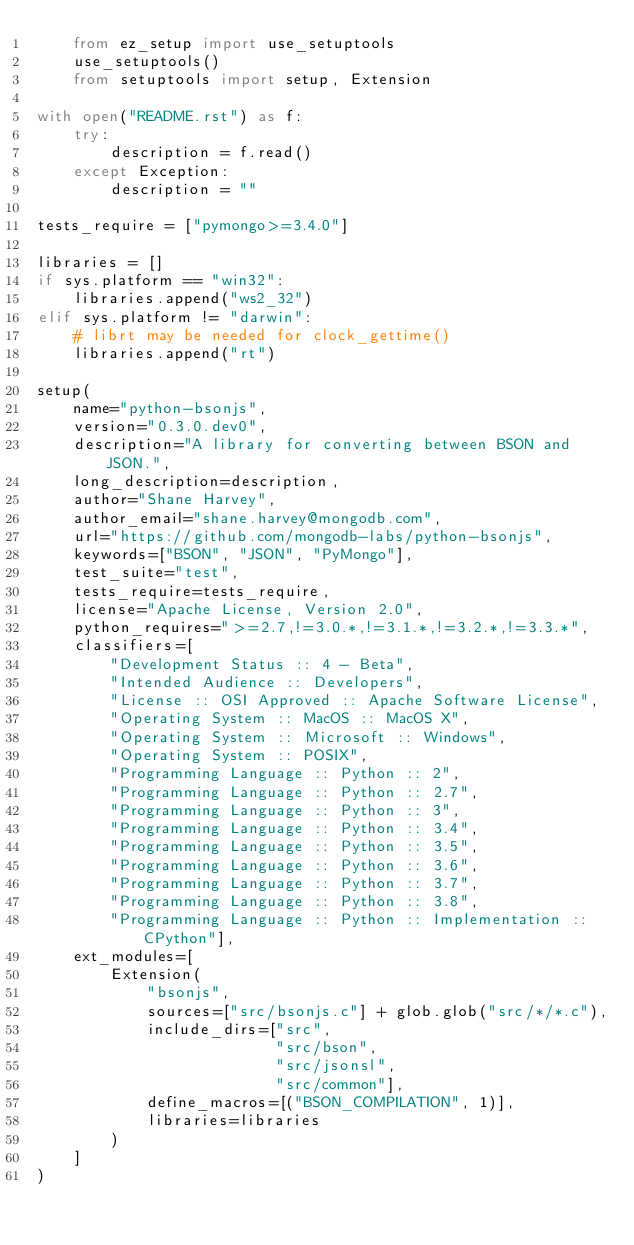<code> <loc_0><loc_0><loc_500><loc_500><_Python_>    from ez_setup import use_setuptools
    use_setuptools()
    from setuptools import setup, Extension

with open("README.rst") as f:
    try:
        description = f.read()
    except Exception:
        description = ""

tests_require = ["pymongo>=3.4.0"]

libraries = []
if sys.platform == "win32":
    libraries.append("ws2_32")
elif sys.platform != "darwin":
    # librt may be needed for clock_gettime()
    libraries.append("rt")

setup(
    name="python-bsonjs",
    version="0.3.0.dev0",
    description="A library for converting between BSON and JSON.",
    long_description=description,
    author="Shane Harvey",
    author_email="shane.harvey@mongodb.com",
    url="https://github.com/mongodb-labs/python-bsonjs",
    keywords=["BSON", "JSON", "PyMongo"],
    test_suite="test",
    tests_require=tests_require,
    license="Apache License, Version 2.0",
    python_requires=">=2.7,!=3.0.*,!=3.1.*,!=3.2.*,!=3.3.*",
    classifiers=[
        "Development Status :: 4 - Beta",
        "Intended Audience :: Developers",
        "License :: OSI Approved :: Apache Software License",
        "Operating System :: MacOS :: MacOS X",
        "Operating System :: Microsoft :: Windows",
        "Operating System :: POSIX",
        "Programming Language :: Python :: 2",
        "Programming Language :: Python :: 2.7",
        "Programming Language :: Python :: 3",
        "Programming Language :: Python :: 3.4",
        "Programming Language :: Python :: 3.5",
        "Programming Language :: Python :: 3.6",
        "Programming Language :: Python :: 3.7",
        "Programming Language :: Python :: 3.8",
        "Programming Language :: Python :: Implementation :: CPython"],
    ext_modules=[
        Extension(
            "bsonjs",
            sources=["src/bsonjs.c"] + glob.glob("src/*/*.c"),
            include_dirs=["src",
                          "src/bson",
                          "src/jsonsl",
                          "src/common"],
            define_macros=[("BSON_COMPILATION", 1)],
            libraries=libraries
        )
    ]
)
</code> 